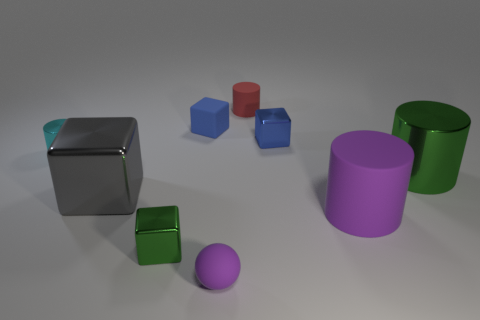Subtract all large rubber cylinders. How many cylinders are left? 3 Subtract all cyan cylinders. How many cylinders are left? 3 Add 1 blue matte things. How many objects exist? 10 Subtract all yellow cylinders. How many blue cubes are left? 2 Subtract all cylinders. How many objects are left? 5 Subtract all green metal blocks. Subtract all brown cylinders. How many objects are left? 8 Add 4 big matte cylinders. How many big matte cylinders are left? 5 Add 2 big cubes. How many big cubes exist? 3 Subtract 0 blue cylinders. How many objects are left? 9 Subtract all cyan balls. Subtract all brown cylinders. How many balls are left? 1 